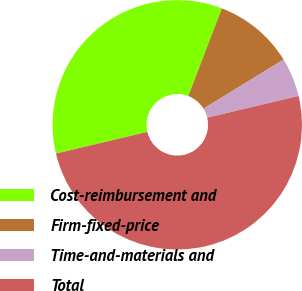Convert chart to OTSL. <chart><loc_0><loc_0><loc_500><loc_500><pie_chart><fcel>Cost-reimbursement and<fcel>Firm-fixed-price<fcel>Time-and-materials and<fcel>Total<nl><fcel>34.53%<fcel>10.42%<fcel>5.05%<fcel>50.0%<nl></chart> 